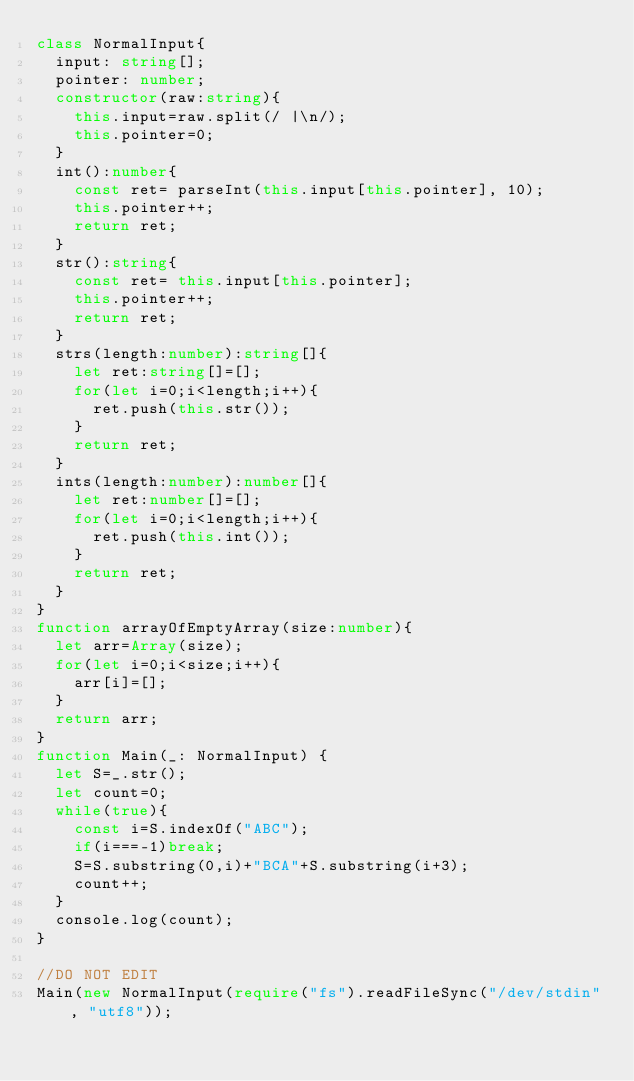<code> <loc_0><loc_0><loc_500><loc_500><_TypeScript_>class NormalInput{
  input: string[];
  pointer: number;
  constructor(raw:string){
    this.input=raw.split(/ |\n/);
    this.pointer=0;
  }
  int():number{
    const ret= parseInt(this.input[this.pointer], 10);
    this.pointer++;
    return ret;
  }
  str():string{
    const ret= this.input[this.pointer];
    this.pointer++;
    return ret;
  }
  strs(length:number):string[]{
    let ret:string[]=[];
    for(let i=0;i<length;i++){
      ret.push(this.str());
    }
    return ret;
  }
  ints(length:number):number[]{
    let ret:number[]=[];
    for(let i=0;i<length;i++){
      ret.push(this.int());
    }
    return ret;
  }
}
function arrayOfEmptyArray(size:number){
  let arr=Array(size);
  for(let i=0;i<size;i++){
    arr[i]=[];
  }
  return arr;
}
function Main(_: NormalInput) {
  let S=_.str();
  let count=0;
  while(true){
    const i=S.indexOf("ABC");
    if(i===-1)break;
    S=S.substring(0,i)+"BCA"+S.substring(i+3);
    count++;
  }
  console.log(count);
}

//DO NOT EDIT
Main(new NormalInput(require("fs").readFileSync("/dev/stdin", "utf8"));
</code> 